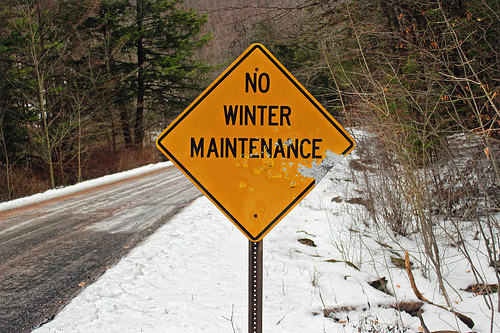<image>
Is the tree behind the sign? Yes. From this viewpoint, the tree is positioned behind the sign, with the sign partially or fully occluding the tree. 